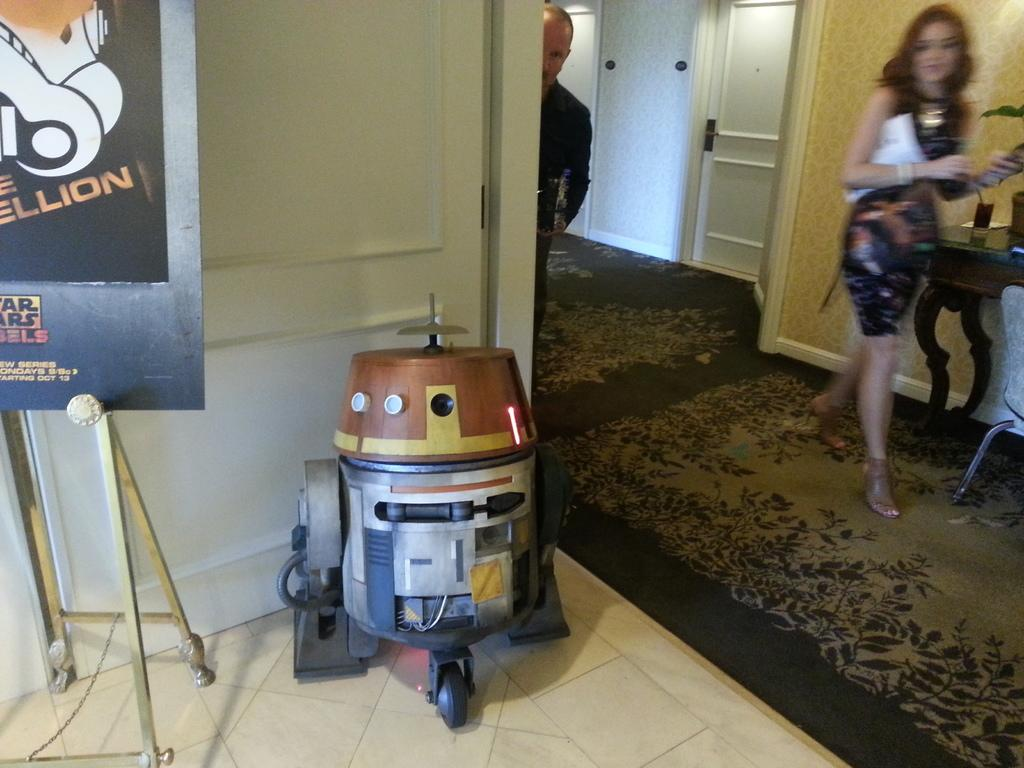Provide a one-sentence caption for the provided image. A poster that is advertising for a Star Wars series. 